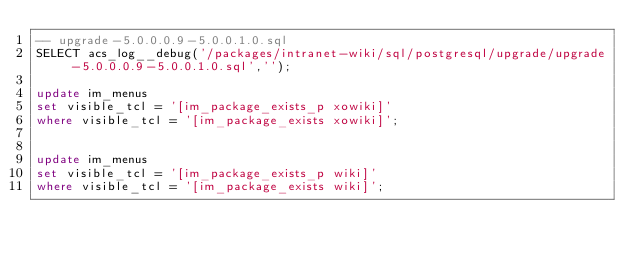<code> <loc_0><loc_0><loc_500><loc_500><_SQL_>-- upgrade-5.0.0.0.9-5.0.0.1.0.sql
SELECT acs_log__debug('/packages/intranet-wiki/sql/postgresql/upgrade/upgrade-5.0.0.0.9-5.0.0.1.0.sql','');

update im_menus
set visible_tcl = '[im_package_exists_p xowiki]'
where visible_tcl = '[im_package_exists xowiki]';


update im_menus
set visible_tcl = '[im_package_exists_p wiki]'
where visible_tcl = '[im_package_exists wiki]';

</code> 